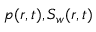Convert formula to latex. <formula><loc_0><loc_0><loc_500><loc_500>p ( r , t ) , S _ { w } ( r , t )</formula> 